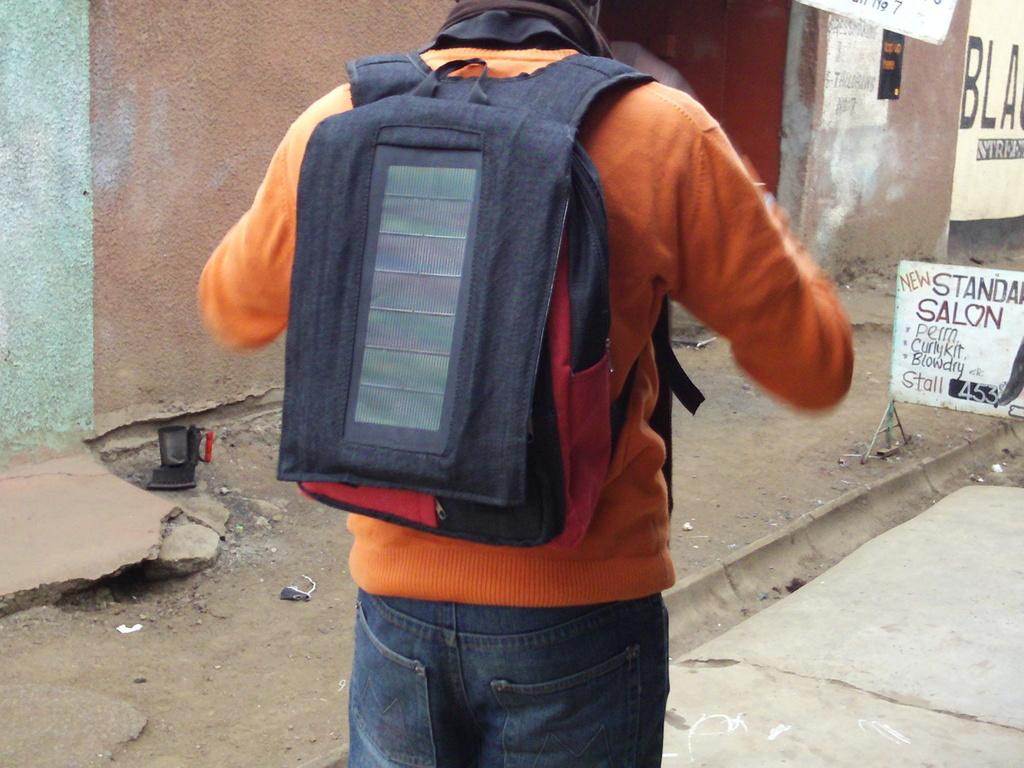<image>
Offer a succinct explanation of the picture presented. A man in an orange sweater has a backpack on by a Salon offering perms. 